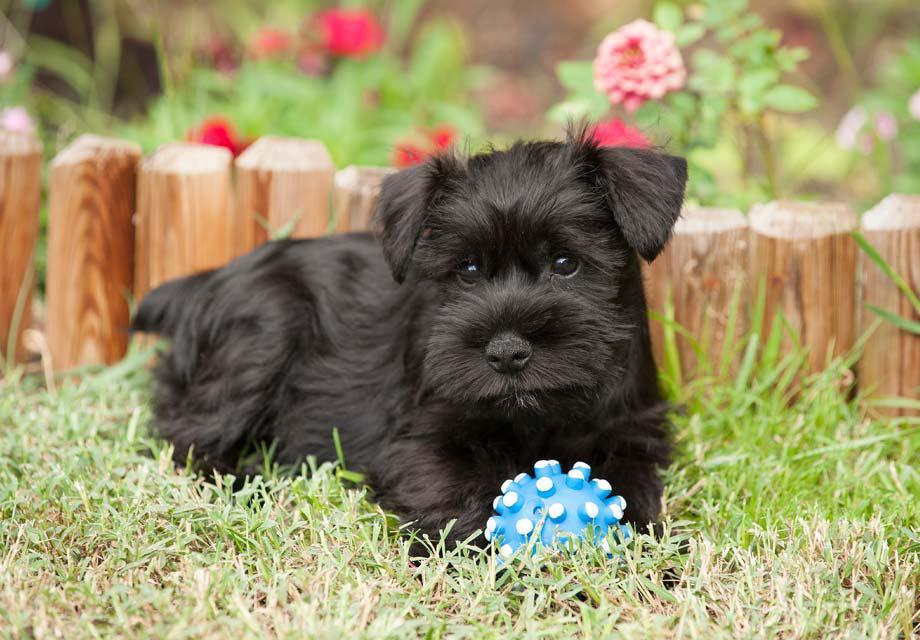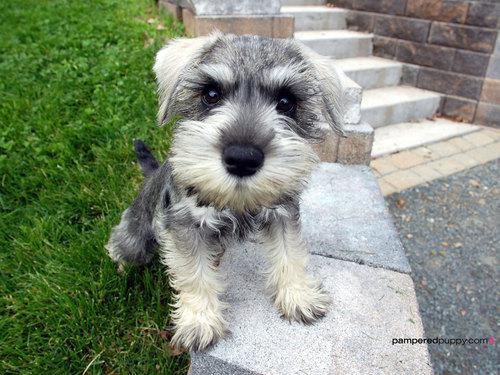The first image is the image on the left, the second image is the image on the right. For the images shown, is this caption "One schnauzer puppy is sitting on its bottom." true? Answer yes or no. Yes. 